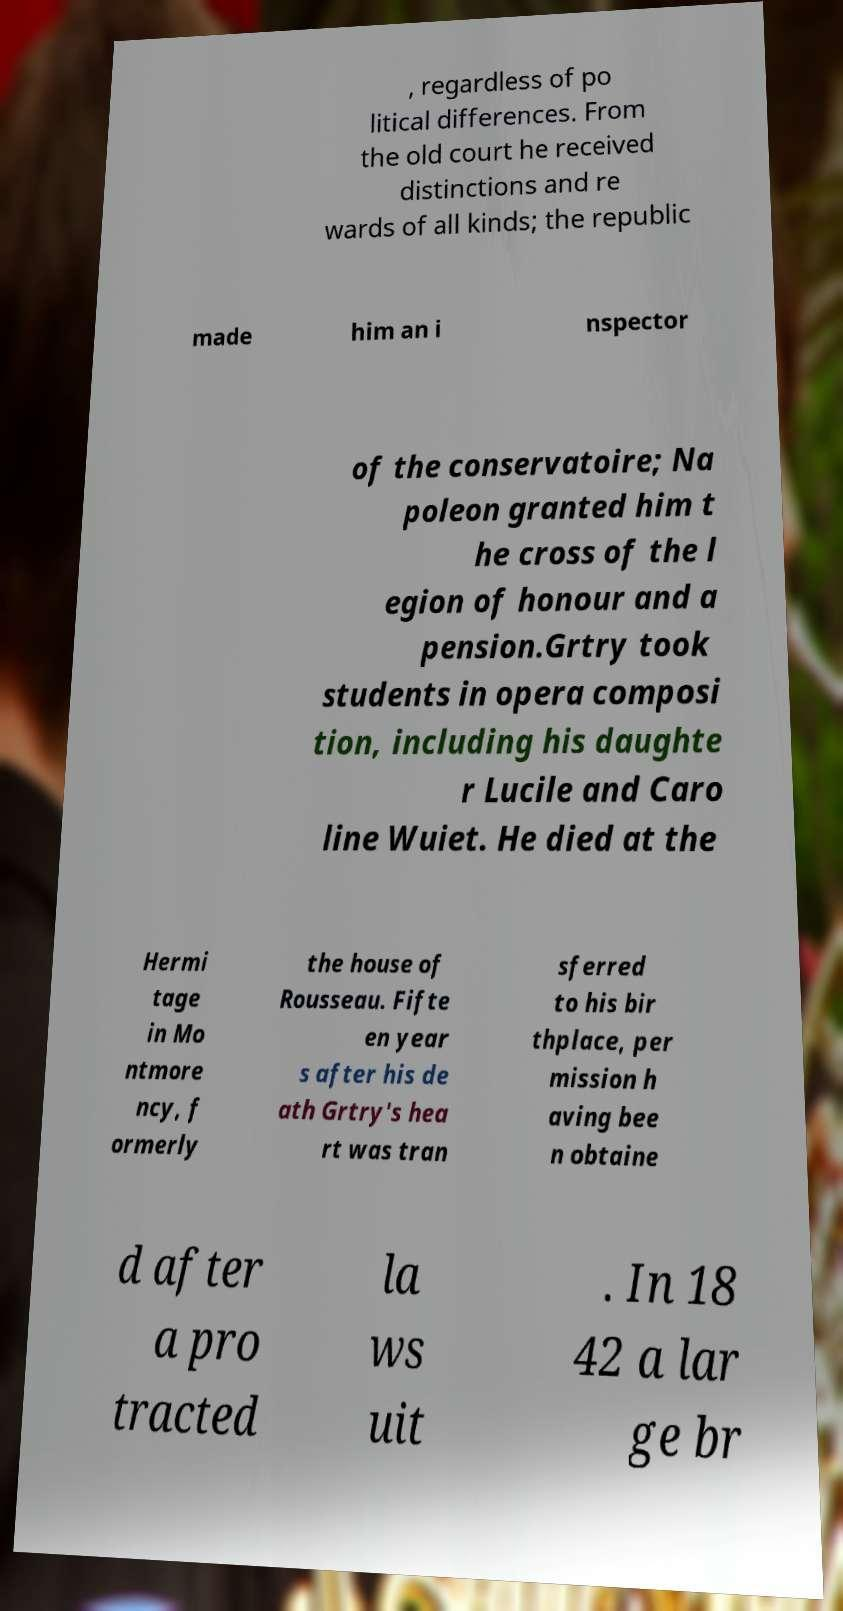For documentation purposes, I need the text within this image transcribed. Could you provide that? , regardless of po litical differences. From the old court he received distinctions and re wards of all kinds; the republic made him an i nspector of the conservatoire; Na poleon granted him t he cross of the l egion of honour and a pension.Grtry took students in opera composi tion, including his daughte r Lucile and Caro line Wuiet. He died at the Hermi tage in Mo ntmore ncy, f ormerly the house of Rousseau. Fifte en year s after his de ath Grtry's hea rt was tran sferred to his bir thplace, per mission h aving bee n obtaine d after a pro tracted la ws uit . In 18 42 a lar ge br 